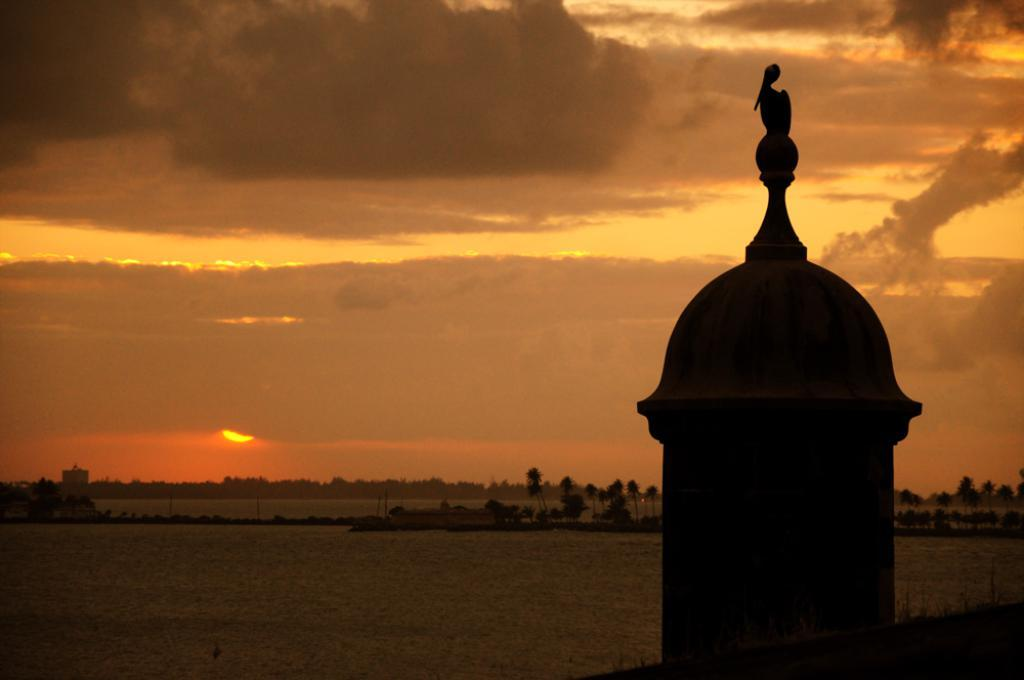What is on top of the pillar in the image? There is a bird on a pillar in the image. What type of vegetation can be seen in the image? There are trees visible in the image. What else can be seen besides the bird and trees? There is water visible in the image. What is visible in the background of the image? The sky is visible in the background of the image. What type of suit is the bird wearing in the image? Birds do not wear suits, so there is no suit present in the image. What activity is the bird performing with the scissors in the image? There are no scissors present in the image, and therefore no such activity can be observed. 